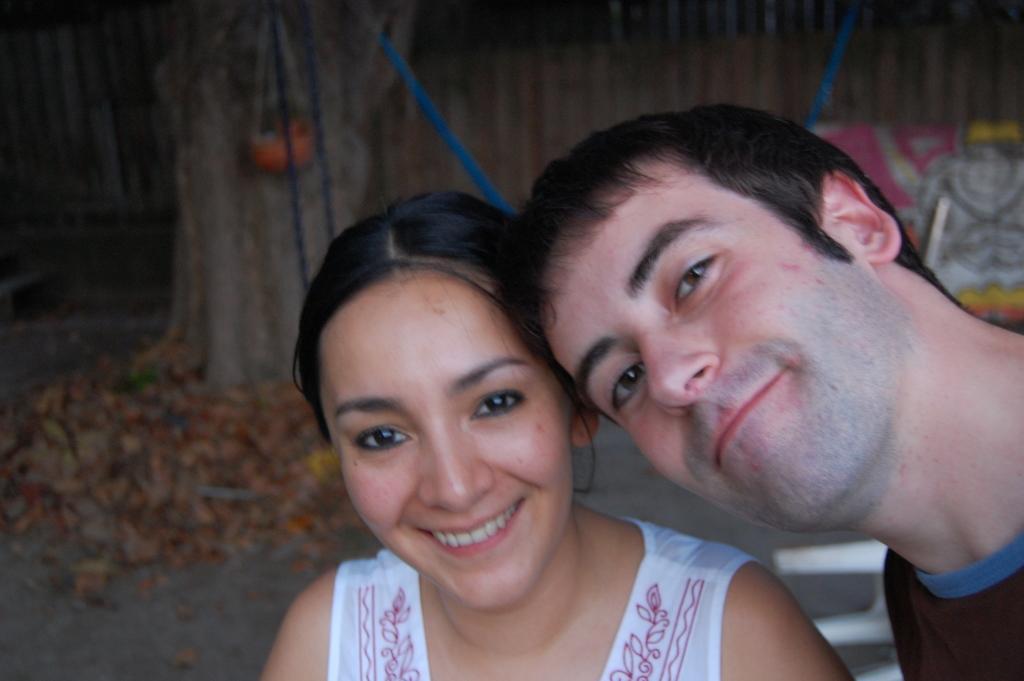In one or two sentences, can you explain what this image depicts? In this image there is a man and a woman in the background it is blurred. 